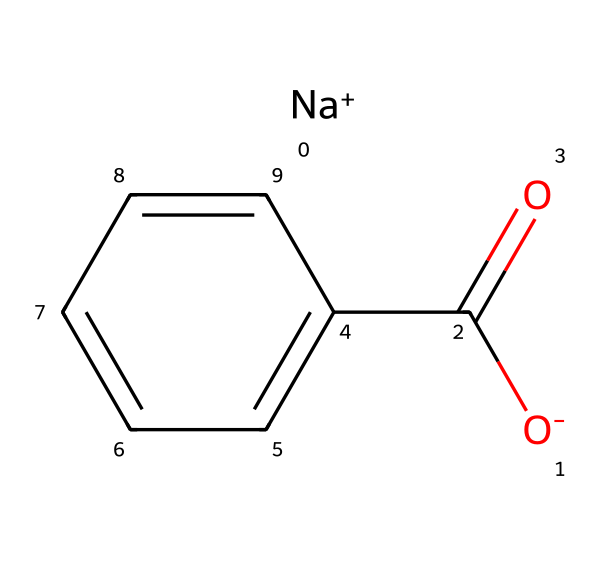What is the main chemical name of this compound? The SMILES representation indicates that the compound consists of a benzoate ion with sodium, which identifies it as sodium benzoate.
Answer: sodium benzoate How many rings are present in the structure? The structure shows a benzene ring, which is a six-membered carbon ring, indicating that there is one ring present.
Answer: one What is the element present in the structure that also indicates the presence of sodium? The presence of [Na+] in the SMILES representation confirms the inclusion of sodium as a cation.
Answer: sodium How many oxygen atoms are there in this compound? Analyzing the SMILES representation reveals two oxygen atoms: one in the carboxylate (–COO–) and one in the carboxylic group (C(=O)).
Answer: two What type of functional group is primarily represented by this compound? The compound features a carboxylate functional group (–COO–), which is characteristic of sodium benzoate and key to its function as a preservative.
Answer: carboxylate Why is sodium benzoate effective as a food preservative? Sodium benzoate inhibits the growth of molds, yeasts, and some bacteria, primarily due to the acidic conditions it creates in food, which affects microbial metabolism.
Answer: inhibits growth What is the effect of pH on the efficacy of sodium benzoate as a preservative? Sodium benzoate is more effective at a lower pH because it remains in the undissociated form at acidic conditions, allowing it to penetrate microbial cell membranes.
Answer: increases efficacy 